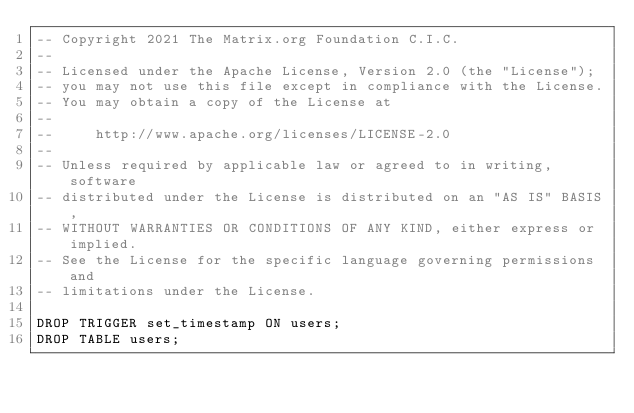<code> <loc_0><loc_0><loc_500><loc_500><_SQL_>-- Copyright 2021 The Matrix.org Foundation C.I.C.
--
-- Licensed under the Apache License, Version 2.0 (the "License");
-- you may not use this file except in compliance with the License.
-- You may obtain a copy of the License at
--
--     http://www.apache.org/licenses/LICENSE-2.0
--
-- Unless required by applicable law or agreed to in writing, software
-- distributed under the License is distributed on an "AS IS" BASIS,
-- WITHOUT WARRANTIES OR CONDITIONS OF ANY KIND, either express or implied.
-- See the License for the specific language governing permissions and
-- limitations under the License.

DROP TRIGGER set_timestamp ON users;
DROP TABLE users;
</code> 